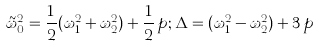<formula> <loc_0><loc_0><loc_500><loc_500>\tilde { \omega } _ { 0 } ^ { 2 } = \frac { 1 } { 2 } ( \omega _ { 1 } ^ { 2 } + \omega _ { 2 } ^ { 2 } ) + \frac { 1 } { 2 } \, p ; \Delta = ( \omega _ { 1 } ^ { 2 } - \omega _ { 2 } ^ { 2 } ) + 3 \, p</formula> 